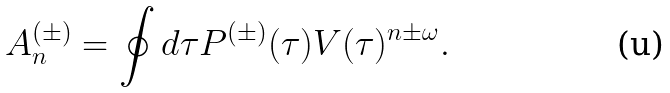<formula> <loc_0><loc_0><loc_500><loc_500>& A ^ { ( \pm ) } _ { n } = \oint d \tau P ^ { ( \pm ) } ( \tau ) V ( \tau ) ^ { n \pm \omega } .</formula> 